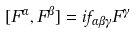Convert formula to latex. <formula><loc_0><loc_0><loc_500><loc_500>[ F ^ { \alpha } , F ^ { \beta } ] = i f _ { \alpha \beta \gamma } F ^ { \gamma }</formula> 